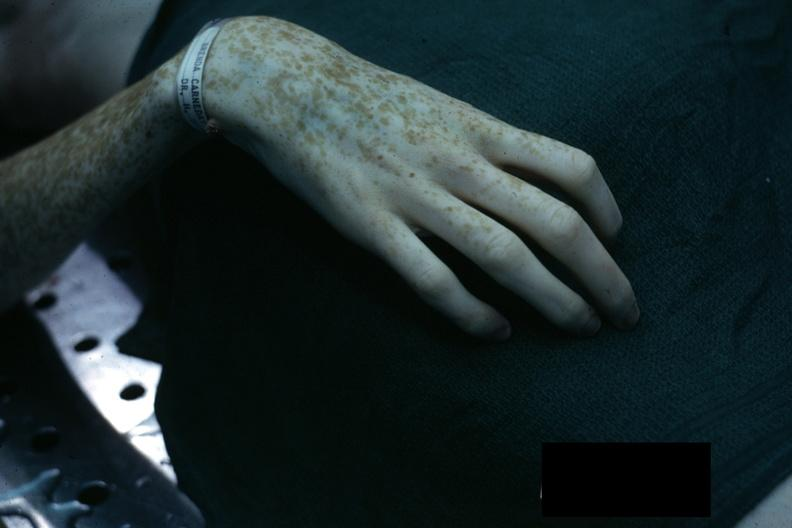what does this image show?
Answer the question using a single word or phrase. Excellent example of marfans syndrome 